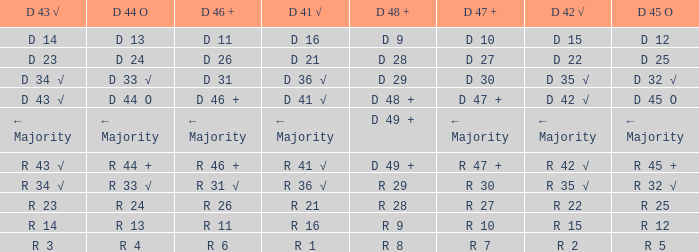What is the value of D 46 +, when the value of D 42 √ is r 2? R 6. 